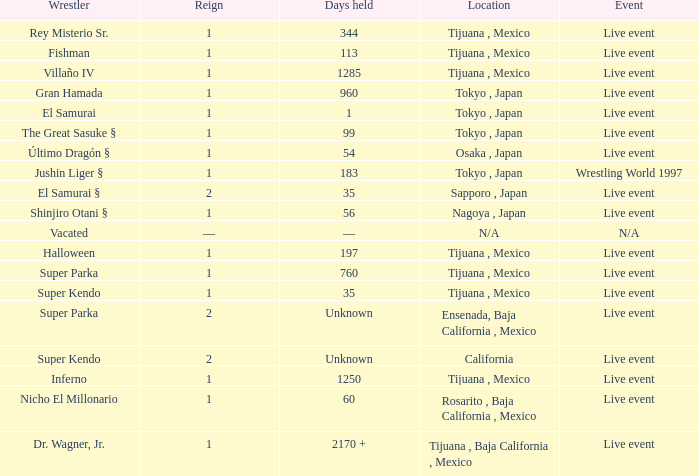Where did the wrestler, super parka, possess the title with a reign duration of 2? Ensenada, Baja California , Mexico. 